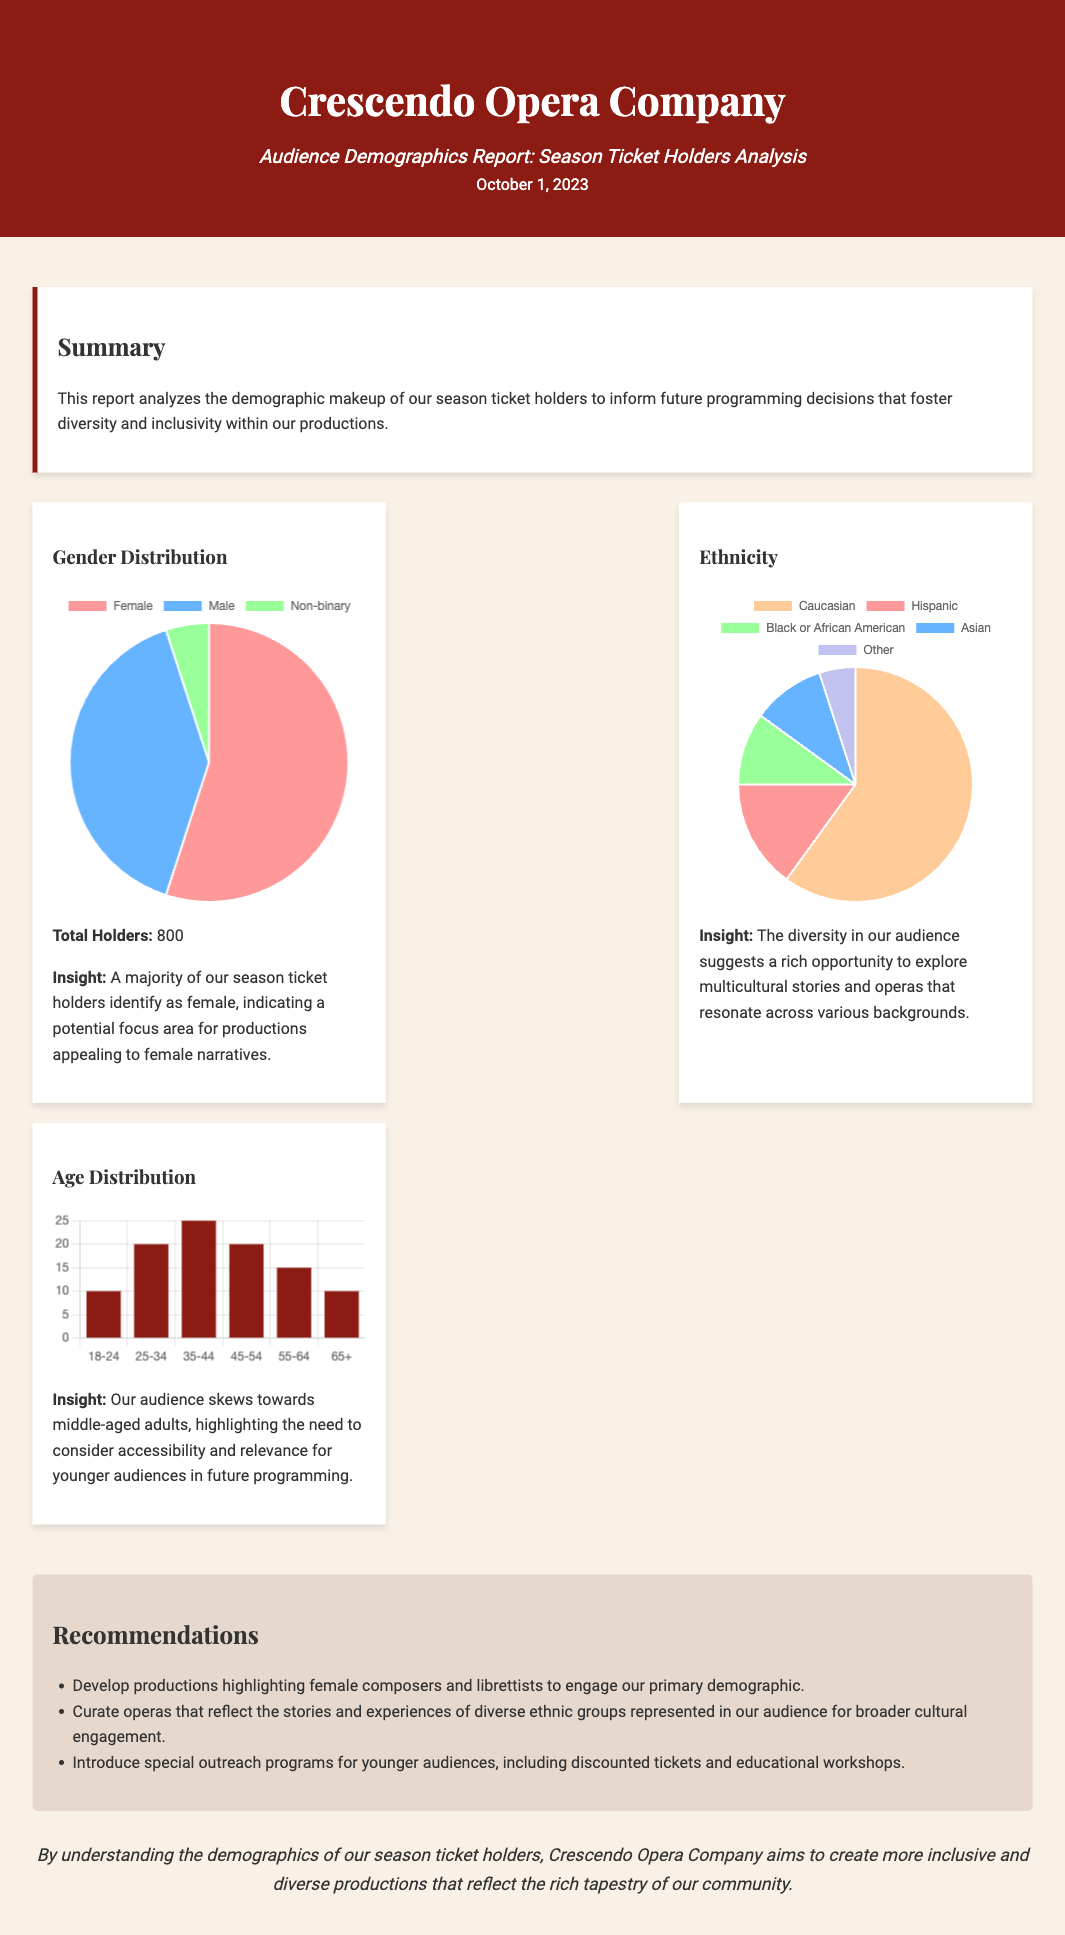What is the total number of season ticket holders? The total number of season ticket holders is provided in the demographics section of the report as 800.
Answer: 800 What percentage of season ticket holders identify as female? The report indicates that 55% of season ticket holders identify as female based on the gender distribution data.
Answer: 55% What is the highest age group percentage among the season ticket holders? The age distribution chart shows that the age group '35-44' has the highest percentage of 25%.
Answer: 25% What ethnicity has the lowest representation among season ticket holders? The ethnicity data reveals that 'Other' is the category with the lowest representation at 5%.
Answer: 5% What recommendation is made to engage the primary demographic? The report recommends developing productions highlighting female composers and librettists.
Answer: Highlight female composers What overall insight is provided about the ethnicity of the audience? The report suggests that the diversity in the audience offers an opportunity for multicultural stories and operas.
Answer: Multicultural stories Which age group has a representation of 20% in the audience? The '25-34' and '45-54' age groups both have a representation of 20% according to the age distribution chart.
Answer: 25-34, 45-54 What are the charts used to present demographic information? The charts used include a pie chart for gender and ethnicity, and a bar chart for age distribution.
Answer: Pie chart, bar chart What color is used for the 'Black or African American' ethnicity category in the chart? The color used for 'Black or African American' in the ethnicity chart is light green.
Answer: Light green 